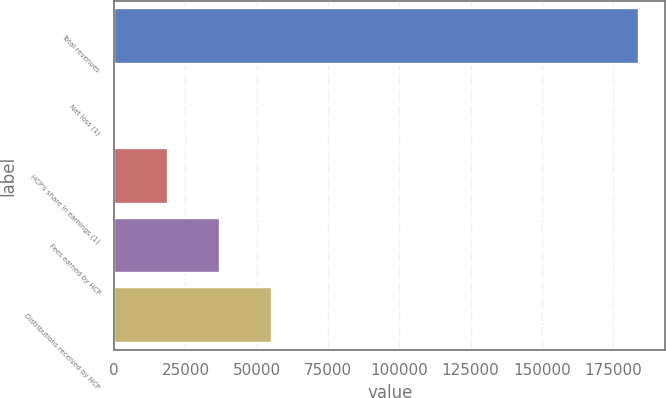Convert chart to OTSL. <chart><loc_0><loc_0><loc_500><loc_500><bar_chart><fcel>Total revenues<fcel>Net loss (1)<fcel>HCP's share in earnings (1)<fcel>Fees earned by HCP<fcel>Distributions received by HCP<nl><fcel>184102<fcel>341<fcel>18717.1<fcel>37093.2<fcel>55469.3<nl></chart> 